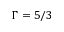Convert formula to latex. <formula><loc_0><loc_0><loc_500><loc_500>\Gamma = 5 / 3</formula> 